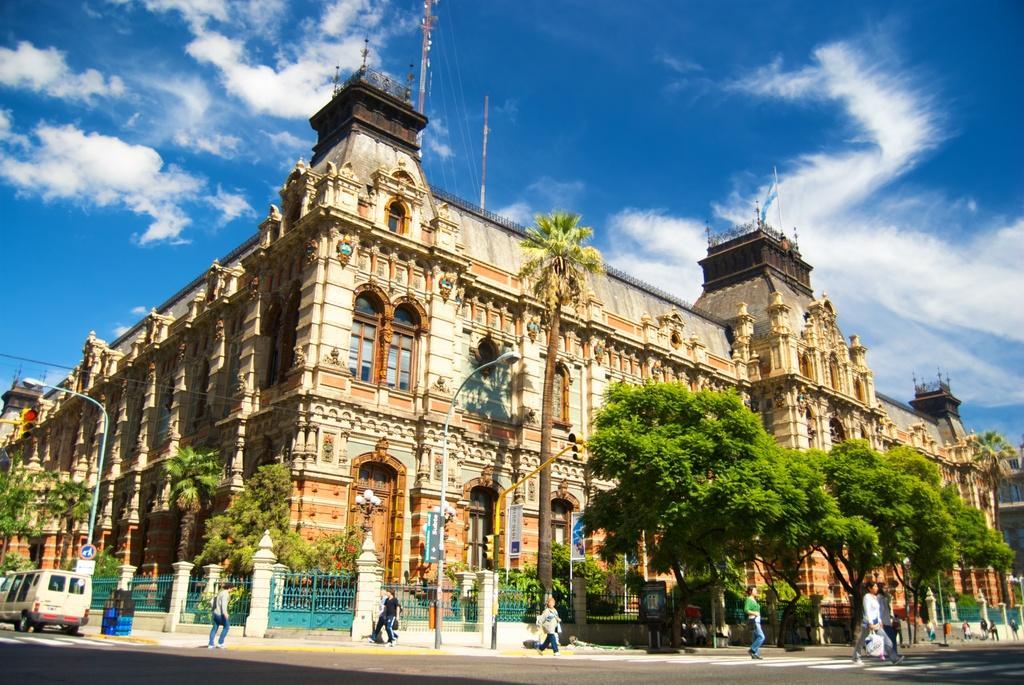How would you summarize this image in a sentence or two? In the center of the image a building is there. On the right side of the image we can see the trees are present. On the left side of the image a truck, electric light pole are present. In the middle of the image we can see the main gate door and some persons are walking. At the top of the image clouds are present in the sky. At the bottom of the image road is present. 